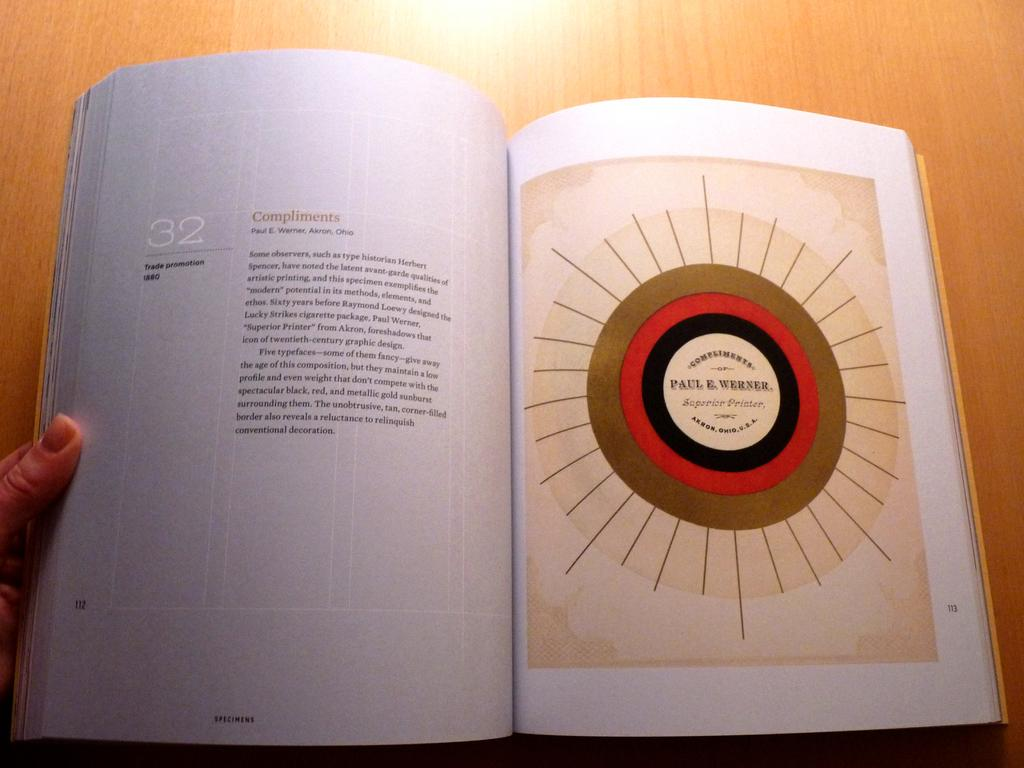<image>
Offer a succinct explanation of the picture presented. A book is opened to page 112 with "Compliments" at the top of the paragraph. 